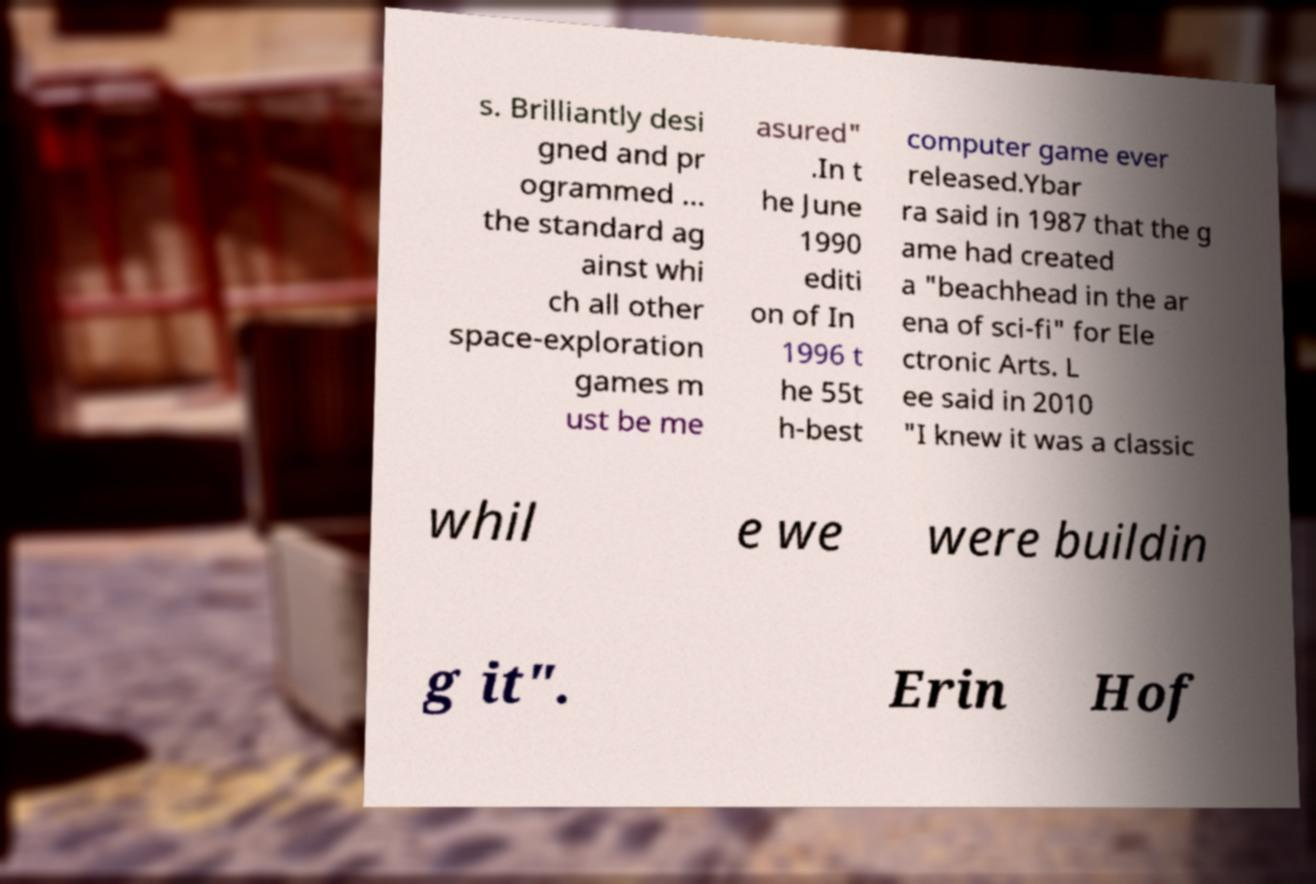I need the written content from this picture converted into text. Can you do that? s. Brilliantly desi gned and pr ogrammed ... the standard ag ainst whi ch all other space-exploration games m ust be me asured" .In t he June 1990 editi on of In 1996 t he 55t h-best computer game ever released.Ybar ra said in 1987 that the g ame had created a "beachhead in the ar ena of sci-fi" for Ele ctronic Arts. L ee said in 2010 "I knew it was a classic whil e we were buildin g it". Erin Hof 